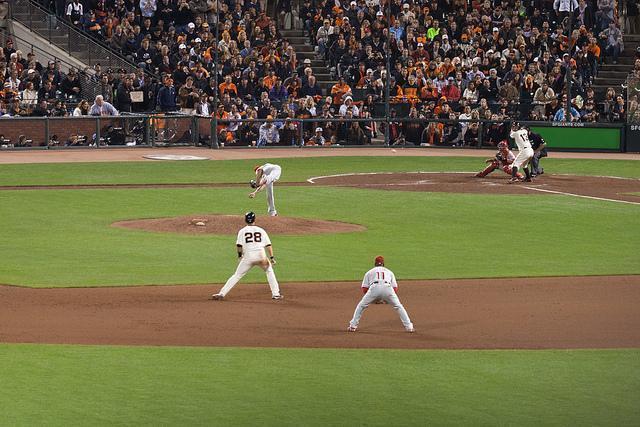Where does baseball come from?
Answer the question by selecting the correct answer among the 4 following choices and explain your choice with a short sentence. The answer should be formatted with the following format: `Answer: choice
Rationale: rationale.`
Options: Sweden, england, america, france. Answer: france.
Rationale: Baseball is america's past time. 